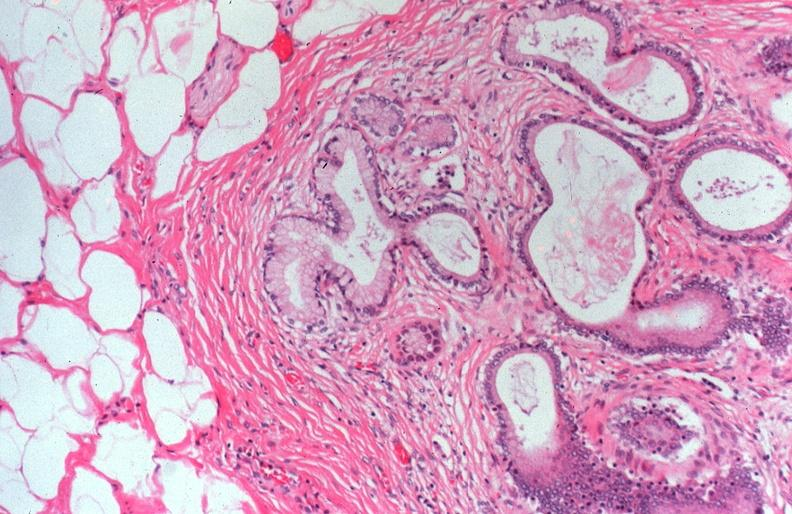s wrights single cell present?
Answer the question using a single word or phrase. No 